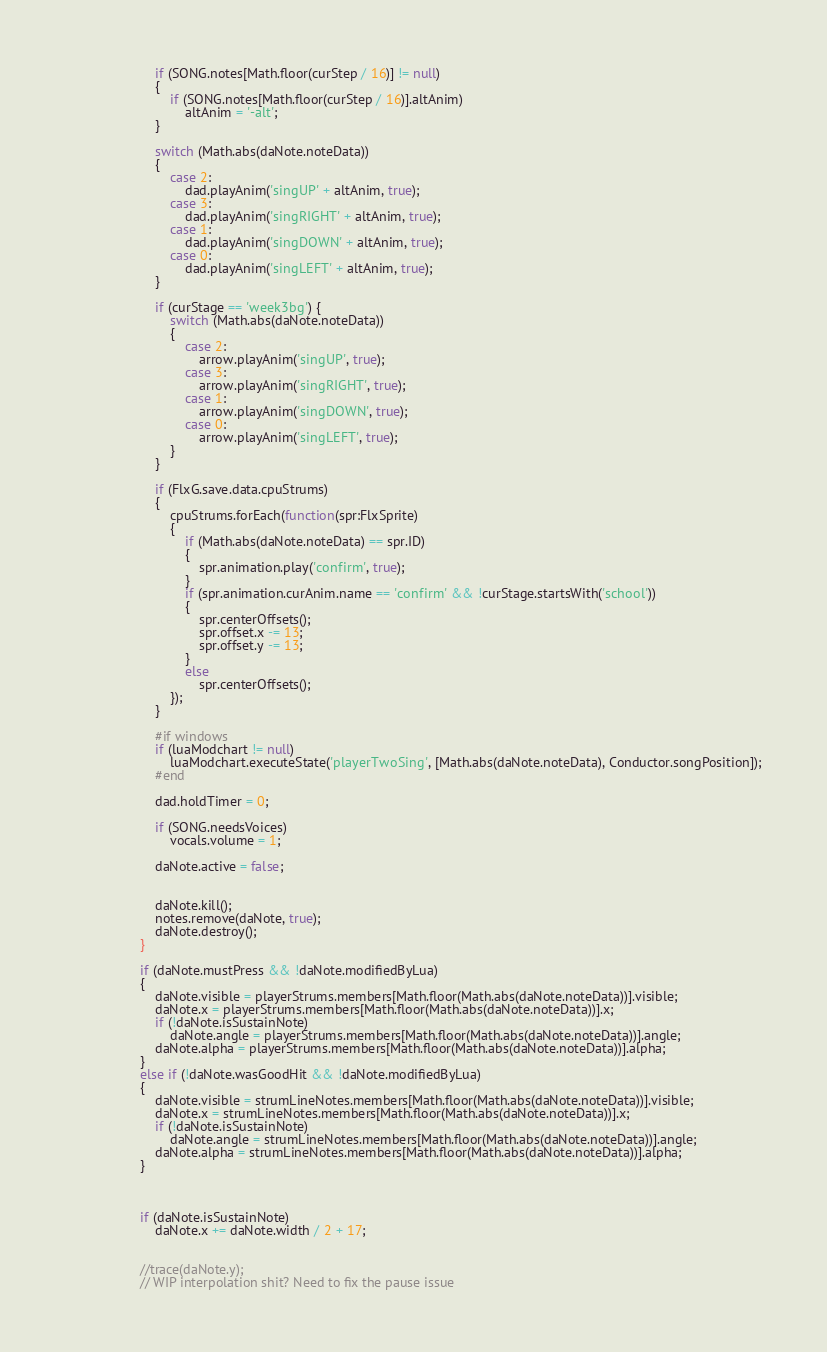Convert code to text. <code><loc_0><loc_0><loc_500><loc_500><_Haxe_>						if (SONG.notes[Math.floor(curStep / 16)] != null)
						{
							if (SONG.notes[Math.floor(curStep / 16)].altAnim)
								altAnim = '-alt';
						}
	
						switch (Math.abs(daNote.noteData))
						{
							case 2:
								dad.playAnim('singUP' + altAnim, true);
							case 3:
								dad.playAnim('singRIGHT' + altAnim, true);
							case 1:
								dad.playAnim('singDOWN' + altAnim, true);
							case 0:
								dad.playAnim('singLEFT' + altAnim, true);
						}

						if (curStage == 'week3bg') {
							switch (Math.abs(daNote.noteData))
							{
								case 2:
									arrow.playAnim('singUP', true);
								case 3:
									arrow.playAnim('singRIGHT', true);
								case 1:
									arrow.playAnim('singDOWN', true);
								case 0:
									arrow.playAnim('singLEFT', true);
							}
						}
						
						if (FlxG.save.data.cpuStrums)
						{
							cpuStrums.forEach(function(spr:FlxSprite)
							{
								if (Math.abs(daNote.noteData) == spr.ID)
								{
									spr.animation.play('confirm', true);
								}
								if (spr.animation.curAnim.name == 'confirm' && !curStage.startsWith('school'))
								{
									spr.centerOffsets();
									spr.offset.x -= 13;
									spr.offset.y -= 13;
								}
								else
									spr.centerOffsets();
							});
						}
	
						#if windows
						if (luaModchart != null)
							luaModchart.executeState('playerTwoSing', [Math.abs(daNote.noteData), Conductor.songPosition]);
						#end

						dad.holdTimer = 0;
	
						if (SONG.needsVoices)
							vocals.volume = 1;
	
						daNote.active = false;


						daNote.kill();
						notes.remove(daNote, true);
						daNote.destroy();
					}

					if (daNote.mustPress && !daNote.modifiedByLua)
					{
						daNote.visible = playerStrums.members[Math.floor(Math.abs(daNote.noteData))].visible;
						daNote.x = playerStrums.members[Math.floor(Math.abs(daNote.noteData))].x;
						if (!daNote.isSustainNote)
							daNote.angle = playerStrums.members[Math.floor(Math.abs(daNote.noteData))].angle;
						daNote.alpha = playerStrums.members[Math.floor(Math.abs(daNote.noteData))].alpha;
					}
					else if (!daNote.wasGoodHit && !daNote.modifiedByLua)
					{
						daNote.visible = strumLineNotes.members[Math.floor(Math.abs(daNote.noteData))].visible;
						daNote.x = strumLineNotes.members[Math.floor(Math.abs(daNote.noteData))].x;
						if (!daNote.isSustainNote)
							daNote.angle = strumLineNotes.members[Math.floor(Math.abs(daNote.noteData))].angle;
						daNote.alpha = strumLineNotes.members[Math.floor(Math.abs(daNote.noteData))].alpha;
					}
					
					

					if (daNote.isSustainNote)
						daNote.x += daNote.width / 2 + 17;
					

					//trace(daNote.y);
					// WIP interpolation shit? Need to fix the pause issue</code> 